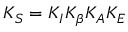<formula> <loc_0><loc_0><loc_500><loc_500>K _ { S } = K _ { I } K _ { \beta } K _ { A } K _ { E }</formula> 